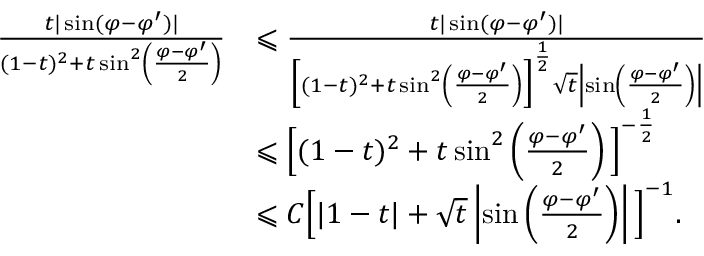<formula> <loc_0><loc_0><loc_500><loc_500>\begin{array} { r l } { \frac { t | \sin ( \varphi - \varphi ^ { \prime } ) | } { ( 1 - t ) ^ { 2 } + t \sin ^ { 2 } \left ( \frac { \varphi - \varphi ^ { \prime } } { 2 } \right ) } } & { \leqslant \frac { t | \sin ( \varphi - \varphi ^ { \prime } ) | } { \left [ ( 1 - t ) ^ { 2 } + t \sin ^ { 2 } \left ( \frac { \varphi - \varphi ^ { \prime } } { 2 } \right ) \right ] ^ { \frac { 1 } { 2 } } \sqrt { t } \left | \sin \left ( \frac { \varphi - \varphi ^ { \prime } } { 2 } \right ) \right | } } \\ & { \leqslant \left [ ( 1 - t ) ^ { 2 } + t \sin ^ { 2 } \left ( \frac { \varphi - \varphi ^ { \prime } } { 2 } \right ) \right ] ^ { - \frac { 1 } { 2 } } } \\ & { \leqslant C \left [ | 1 - t | + \sqrt { t } \left | \sin \left ( \frac { \varphi - \varphi ^ { \prime } } { 2 } \right ) \right | \right ] ^ { - 1 } . } \end{array}</formula> 